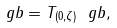Convert formula to latex. <formula><loc_0><loc_0><loc_500><loc_500>\ g b = T _ { ( 0 , \zeta ) } \ g b ,</formula> 